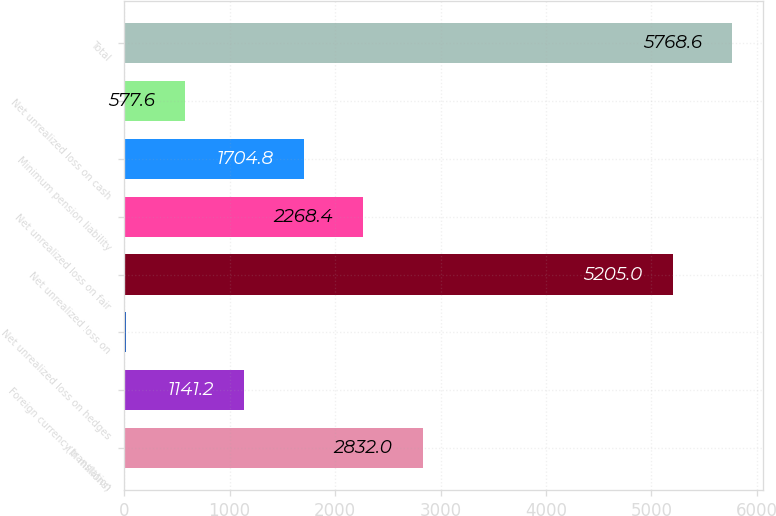Convert chart to OTSL. <chart><loc_0><loc_0><loc_500><loc_500><bar_chart><fcel>(In millions)<fcel>Foreign currency translation<fcel>Net unrealized loss on hedges<fcel>Net unrealized loss on<fcel>Net unrealized loss on fair<fcel>Minimum pension liability<fcel>Net unrealized loss on cash<fcel>Total<nl><fcel>2832<fcel>1141.2<fcel>14<fcel>5205<fcel>2268.4<fcel>1704.8<fcel>577.6<fcel>5768.6<nl></chart> 